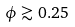<formula> <loc_0><loc_0><loc_500><loc_500>\phi \gtrsim 0 . 2 5</formula> 